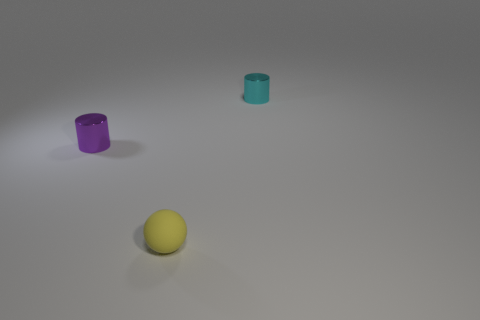There is a cylinder in front of the tiny metal thing right of the small cylinder to the left of the small yellow rubber sphere; what is it made of?
Provide a short and direct response. Metal. Is there anything else that is the same size as the purple shiny object?
Your answer should be compact. Yes. What number of rubber things are either tiny purple cylinders or tiny blue cubes?
Provide a succinct answer. 0. Are there any purple shiny cylinders?
Ensure brevity in your answer.  Yes. There is a tiny rubber thing in front of the small shiny object that is behind the purple shiny cylinder; what color is it?
Offer a very short reply. Yellow. How many other objects are the same color as the matte sphere?
Offer a terse response. 0. What number of things are either tiny cyan cylinders or small shiny cylinders to the left of the small cyan metallic object?
Offer a very short reply. 2. The tiny cylinder on the right side of the matte ball is what color?
Your response must be concise. Cyan. The tiny purple object has what shape?
Your answer should be compact. Cylinder. There is a object that is behind the tiny object that is left of the small yellow ball; what is its material?
Your response must be concise. Metal. 